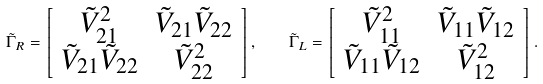Convert formula to latex. <formula><loc_0><loc_0><loc_500><loc_500>\tilde { \Gamma } _ { R } = \left [ \begin{array} { c c } \tilde { V } _ { 2 1 } ^ { 2 } & \tilde { V } _ { 2 1 } \tilde { V } _ { 2 2 } \\ \tilde { V } _ { 2 1 } \tilde { V } _ { 2 2 } & \tilde { V } _ { 2 2 } ^ { 2 } \end{array} \right ] , \quad \tilde { \Gamma } _ { L } = \left [ \begin{array} { c c } \tilde { V } _ { 1 1 } ^ { 2 } & \tilde { V } _ { 1 1 } \tilde { V } _ { 1 2 } \\ \tilde { V } _ { 1 1 } \tilde { V } _ { 1 2 } & \tilde { V } _ { 1 2 } ^ { 2 } \end{array} \right ] .</formula> 